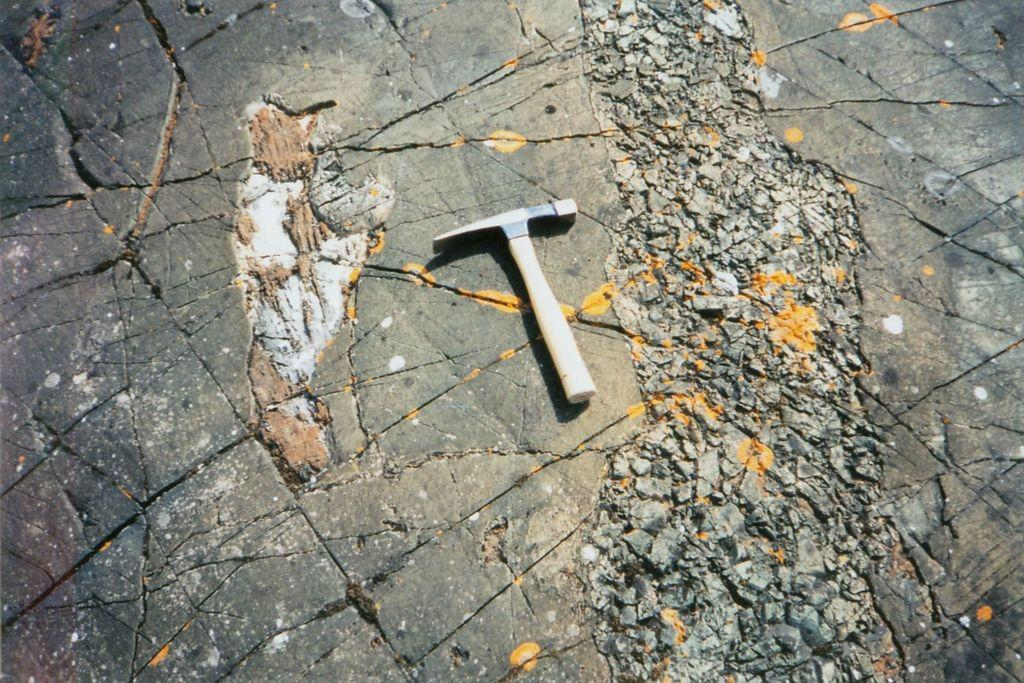What object is in the center of the image? The geologist's hammer is in the center of the image. Where is the geologist's hammer located? The geologist's hammer is on the floor. What type of flower is growing at the end of the image? There is no flower present in the image; it features a geologist's hammer on the floor. What team is responsible for placing the geologist's hammer in the image? There is no team involved in placing the geologist's hammer in the image; it is simply an object in the scene. 